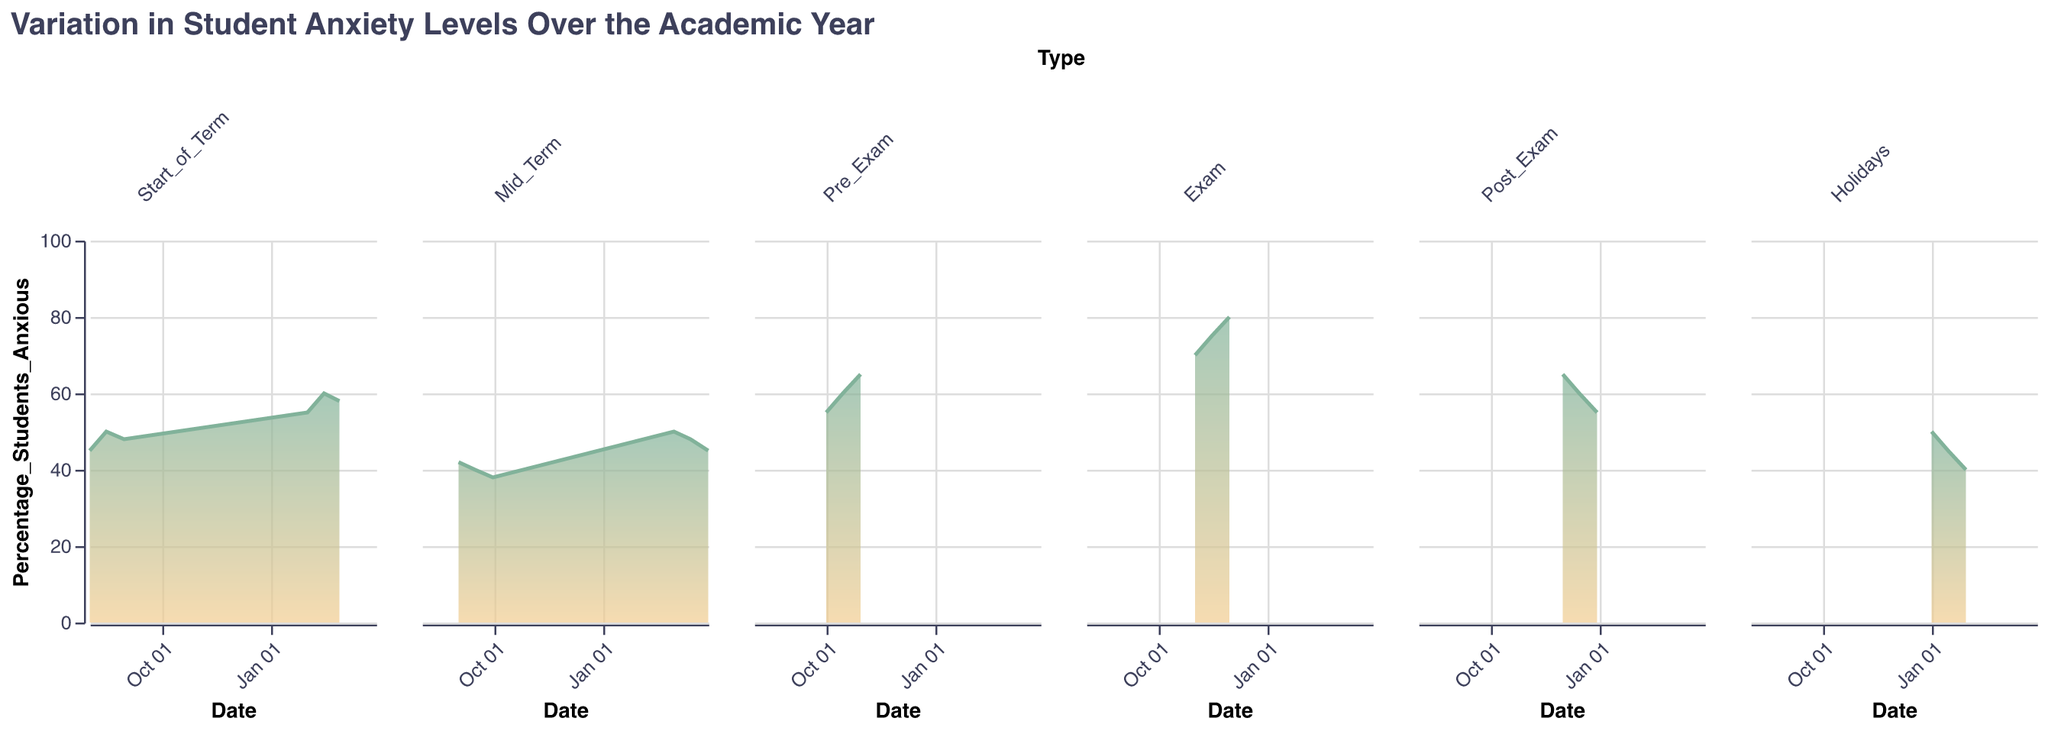What is the title of the figure? The title is found at the top of the figure and is clearly indicated
Answer: Variation in Student Anxiety Levels Over the Academic Year What is the highest level of anxiety recorded during the exam period? Look at the subplot for the "Exam" period and identify the highest point on the y-axis
Answer: 80% During which period did the anxiety level start at 45% and drop to 40% by the end of the period? Check each period's subplot for the range where the anxiety level starts at 45% and drops to 40%
Answer: Holidays Which period shows the biggest increase in anxiety over time? Examine each subplot and compare the starting and ending points to find the largest increase
Answer: Exam What is the difference in anxiety levels between the start and end of the "Pre_Exam" period? Look at the "Pre_Exam" subplot and subtract the starting percentage from the ending percentage (65% - 55%)
Answer: 10% What is the average anxiety level during the "Start_of_Term" periods? Calculate the average from all data points in the "Start_of_Term" subplots: (45 + 50 + 48 + 55 + 60 + 58) / 6
Answer: 52.67% Which period shows the steady decrease in anxiety levels? Identify a period where anxiety levels continuously drop; this can be found in the "Mid_Term" subplot
Answer: Mid_Term How does the anxiety level at the start of the term compare to that at the start of the holidays? Compare the first data point in the "Start_of_Term" subplot (45%) with the first data point in the "Holidays" subplot (50%)
Answer: Anxiety is higher at the start of the holidays What trend is observed in the anxiety levels post-exam? Look at the "Post_Exam" subplot and observe the general direction of the curve
Answer: The anxiety levels gradually decrease Does the anxiety level ever reach 70% in any period other than exams? Check each subplot for any data points that hit 70%
Answer: No 